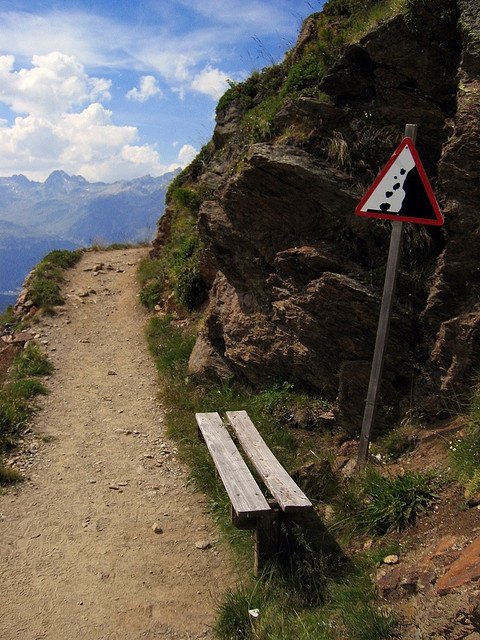Describe the objects in this image and their specific colors. I can see a bench in darkgray, black, and lightgray tones in this image. 